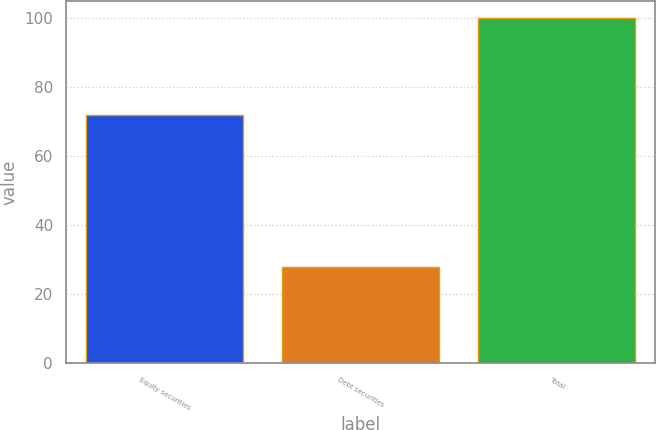Convert chart. <chart><loc_0><loc_0><loc_500><loc_500><bar_chart><fcel>Equity securities<fcel>Debt securities<fcel>Total<nl><fcel>72<fcel>28<fcel>100<nl></chart> 